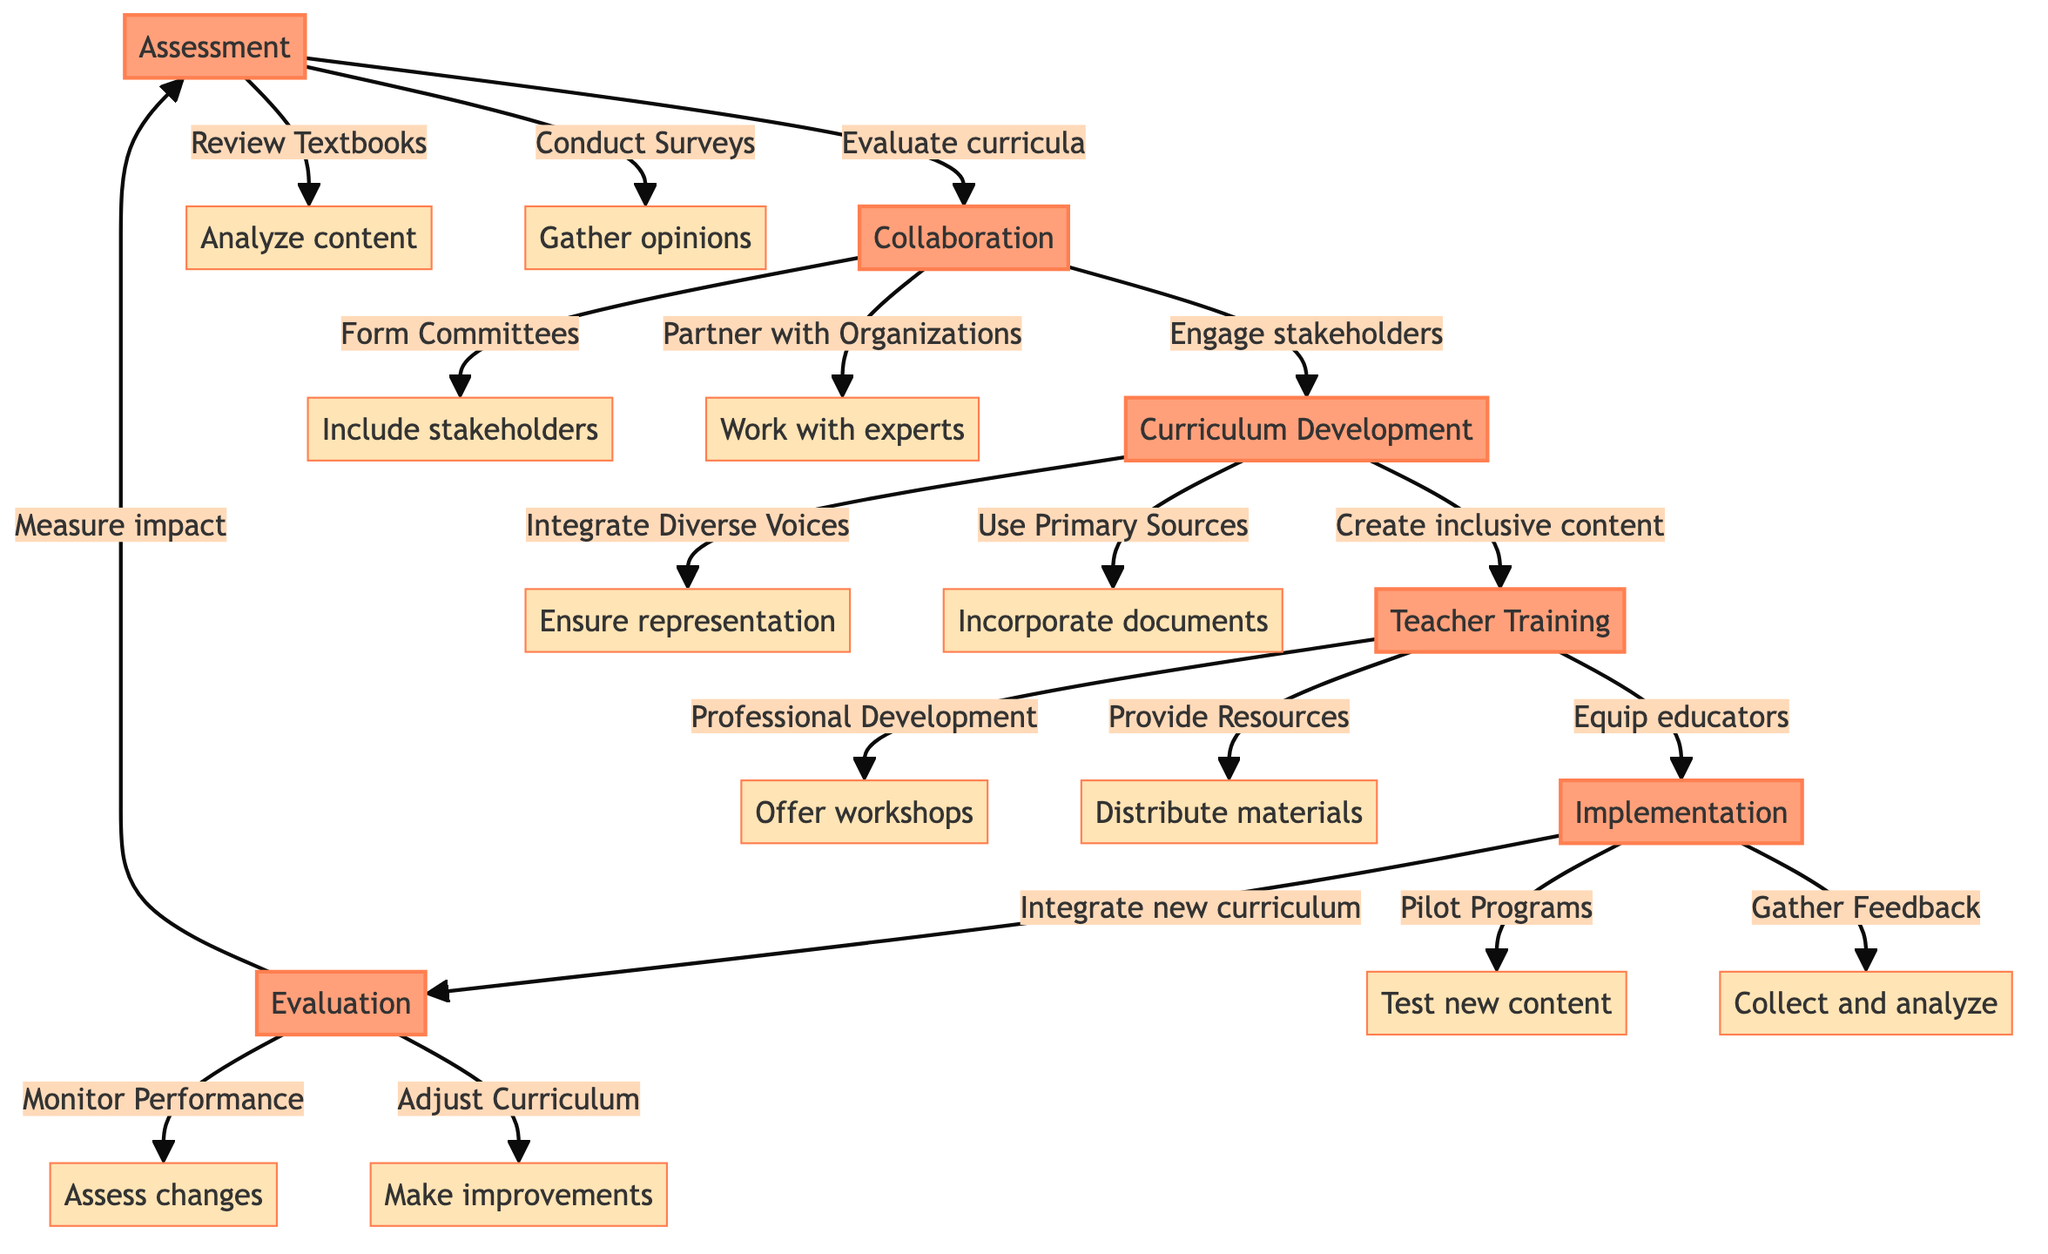What is the first step in the pathway? The first step in the pathway is labeled as "Assessment," which is indicated as the starting point in the diagram.
Answer: Assessment How many main steps are there in total? There are six main steps in the diagram: Assessment, Collaboration, Curriculum Development, Teacher Training, Implementation, and Evaluation.
Answer: Six What action is taken during the "Collaboration" step? During the "Collaboration" step, actions include forming committees and partnering with organizations, as depicted in the diagram.
Answer: Form Committees, Partner with Organizations Which step involves reviewing textbooks? The step involving reviewing textbooks is "Assessment," as shown in the diagram where the action connects directly to this step.
Answer: Assessment What is the purpose of "Teacher Training"? The purpose of "Teacher Training" is to equip educators with tools and knowledge, as defined in the step description in the diagram.
Answer: Equip educators with tools and knowledge What are the two actions that occur during "Implementation"? The two actions that occur during "Implementation" are "Pilot Programs" and "Gather Feedback," connecting to this step in the diagram.
Answer: Pilot Programs, Gather Feedback How does the "Evaluation" step relate to previous actions? The "Evaluation" step relates to previous actions by measuring impact and refining the curriculum based on the feedback and outcomes from the actions taken earlier in the pathway.
Answer: Measure impact and refine What is an example of integrating diverse voices in the curriculum? An example of integrating diverse voices in the curriculum is ensuring representation of various cultures and perspectives as stated in the "Curriculum Development" step.
Answer: Ensure representation of various cultures and perspectives What happens after "Gather Feedback"? After "Gather Feedback," the next step in the pathway is "Evaluation," where the feedback collected is used to measure impact.
Answer: Evaluation 